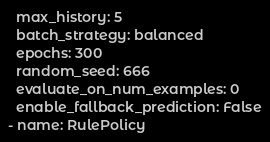<code> <loc_0><loc_0><loc_500><loc_500><_YAML_>  max_history: 5
  batch_strategy: balanced
  epochs: 300 
  random_seed: 666
  evaluate_on_num_examples: 0
  enable_fallback_prediction: False
- name: RulePolicy
</code> 